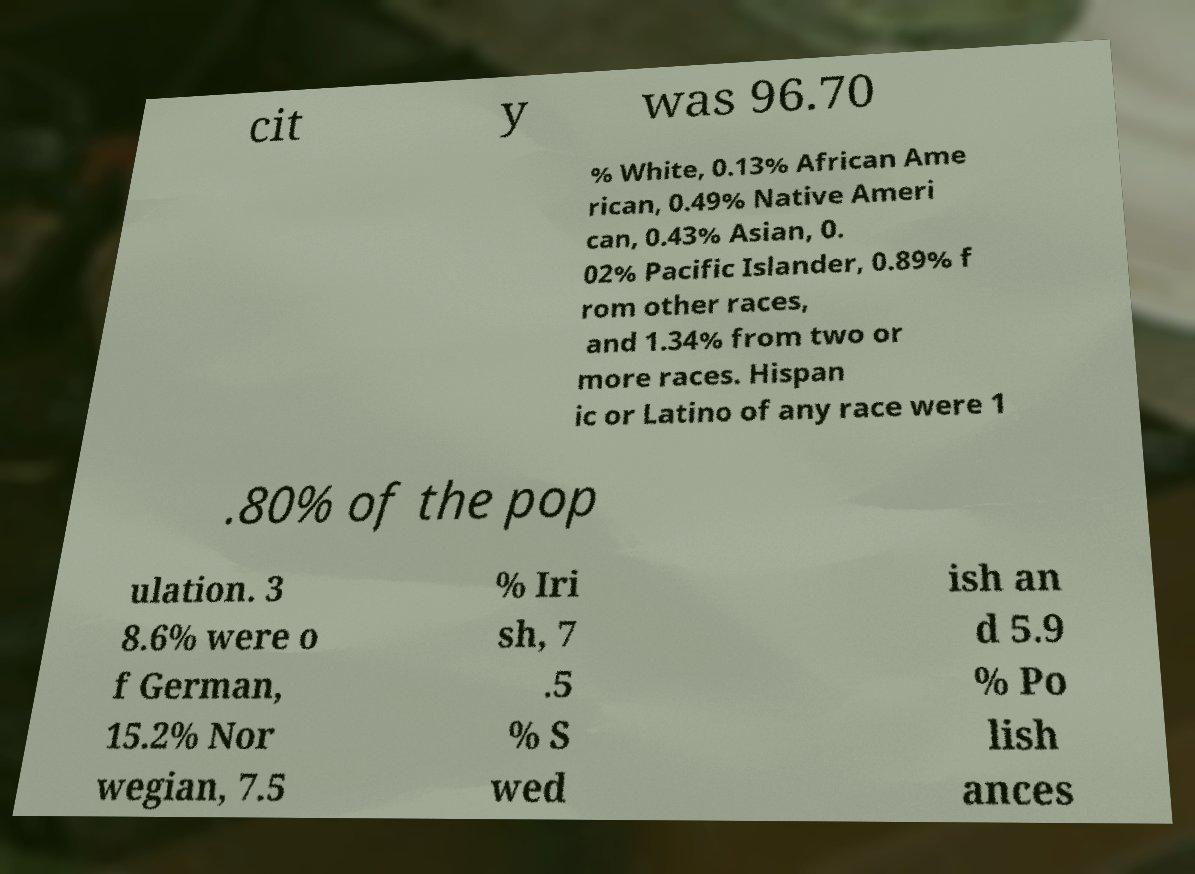Please read and relay the text visible in this image. What does it say? cit y was 96.70 % White, 0.13% African Ame rican, 0.49% Native Ameri can, 0.43% Asian, 0. 02% Pacific Islander, 0.89% f rom other races, and 1.34% from two or more races. Hispan ic or Latino of any race were 1 .80% of the pop ulation. 3 8.6% were o f German, 15.2% Nor wegian, 7.5 % Iri sh, 7 .5 % S wed ish an d 5.9 % Po lish ances 